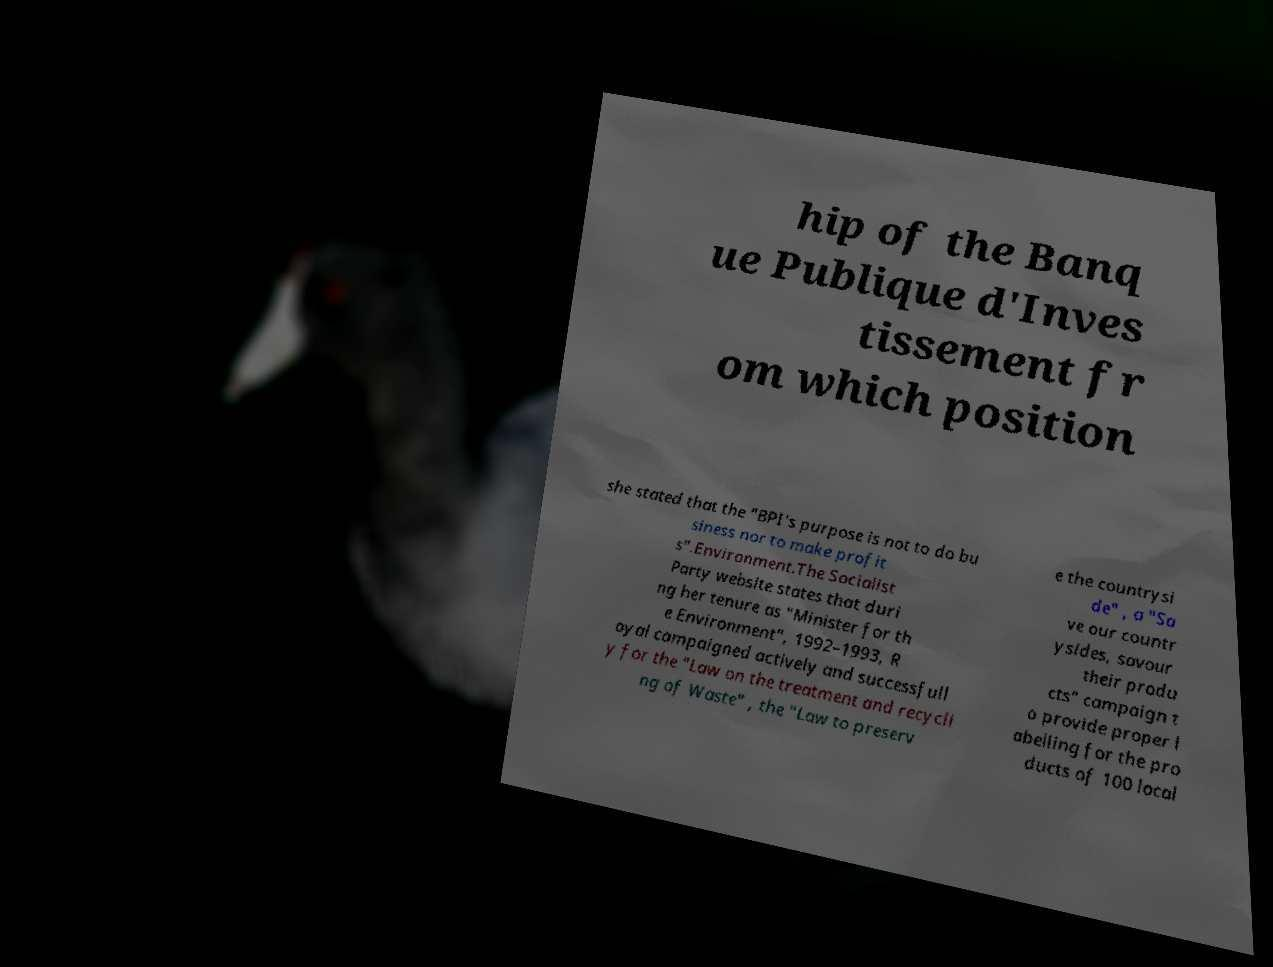What messages or text are displayed in this image? I need them in a readable, typed format. hip of the Banq ue Publique d'Inves tissement fr om which position she stated that the "BPI's purpose is not to do bu siness nor to make profit s".Environment.The Socialist Party website states that duri ng her tenure as "Minister for th e Environment", 1992–1993, R oyal campaigned actively and successfull y for the "Law on the treatment and recycli ng of Waste" , the "Law to preserv e the countrysi de" , a "Sa ve our countr ysides, savour their produ cts" campaign t o provide proper l abelling for the pro ducts of 100 local 